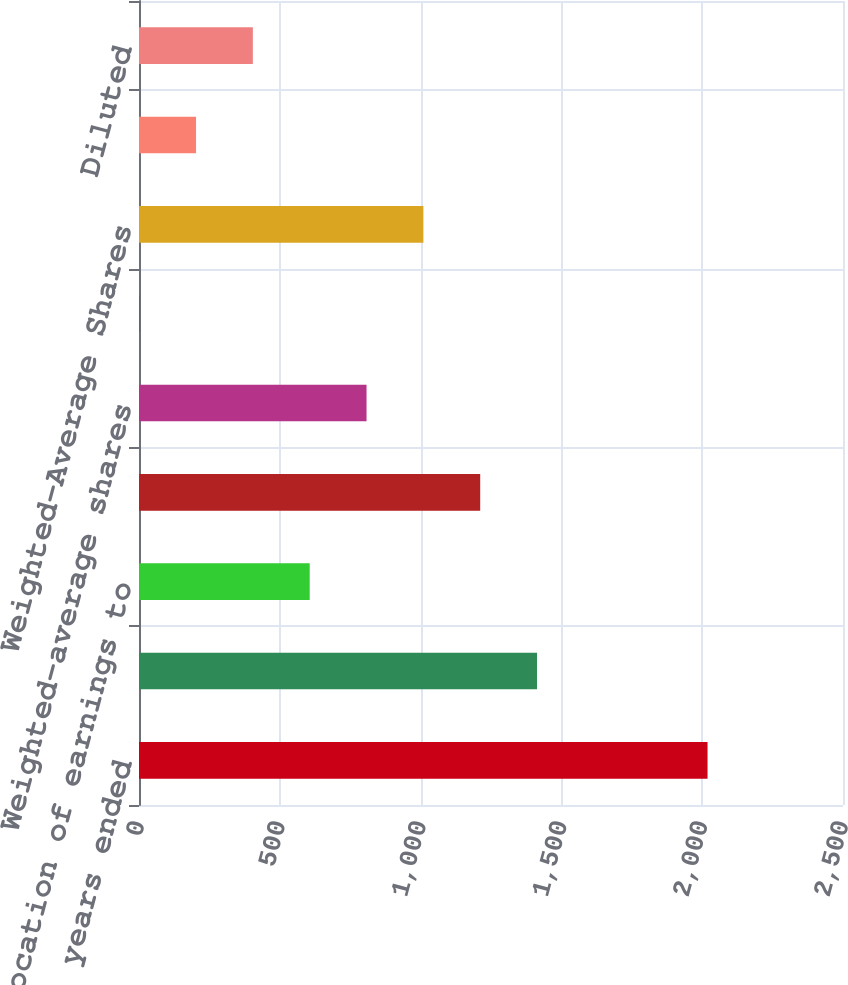<chart> <loc_0><loc_0><loc_500><loc_500><bar_chart><fcel>for the fiscal years ended<fcel>Net income attributable to<fcel>Less allocation of earnings to<fcel>Net Income Available to Common<fcel>Weighted-average shares<fcel>Dilutive effect of<fcel>Weighted-Average Shares<fcel>Basic<fcel>Diluted<nl><fcel>2019<fcel>1413.51<fcel>606.19<fcel>1211.68<fcel>808.02<fcel>0.7<fcel>1009.85<fcel>202.53<fcel>404.36<nl></chart> 